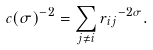<formula> <loc_0><loc_0><loc_500><loc_500>c ( { \sigma } ) ^ { - 2 } = \sum _ { j \neq i } r { _ { i j } } ^ { - 2 \sigma } .</formula> 